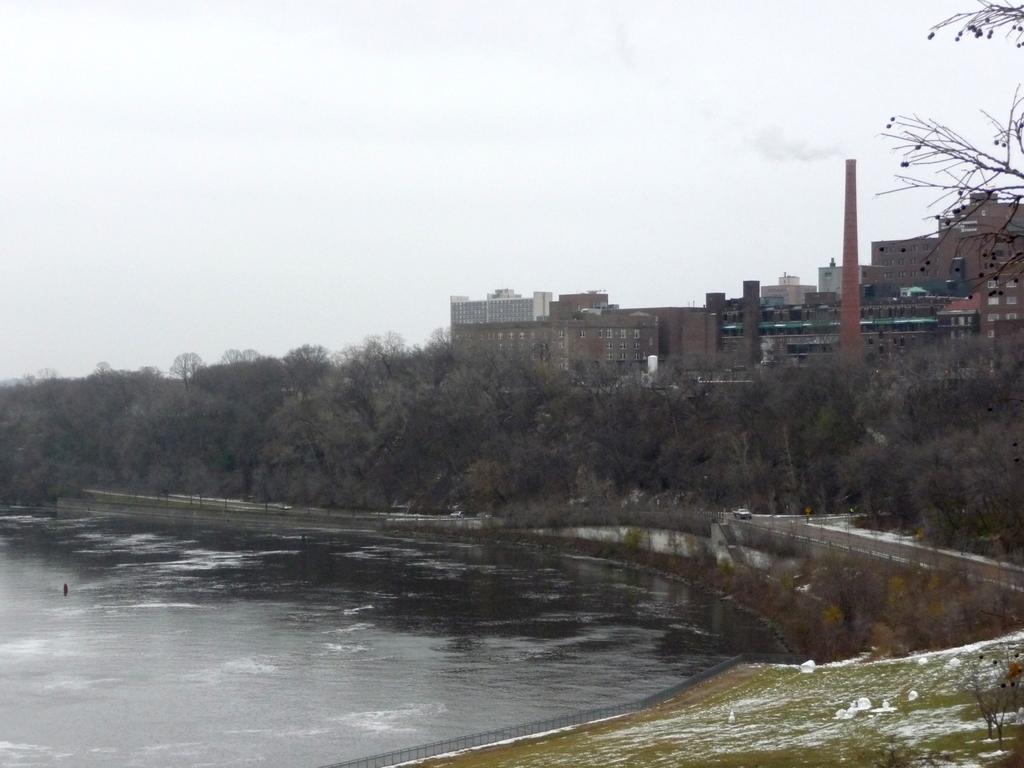How would you summarize this image in a sentence or two? In this picture we can see buildings and trees. At the bottom we can see the water, beside that there is a fencing. On the top we can see sky and clouds. 